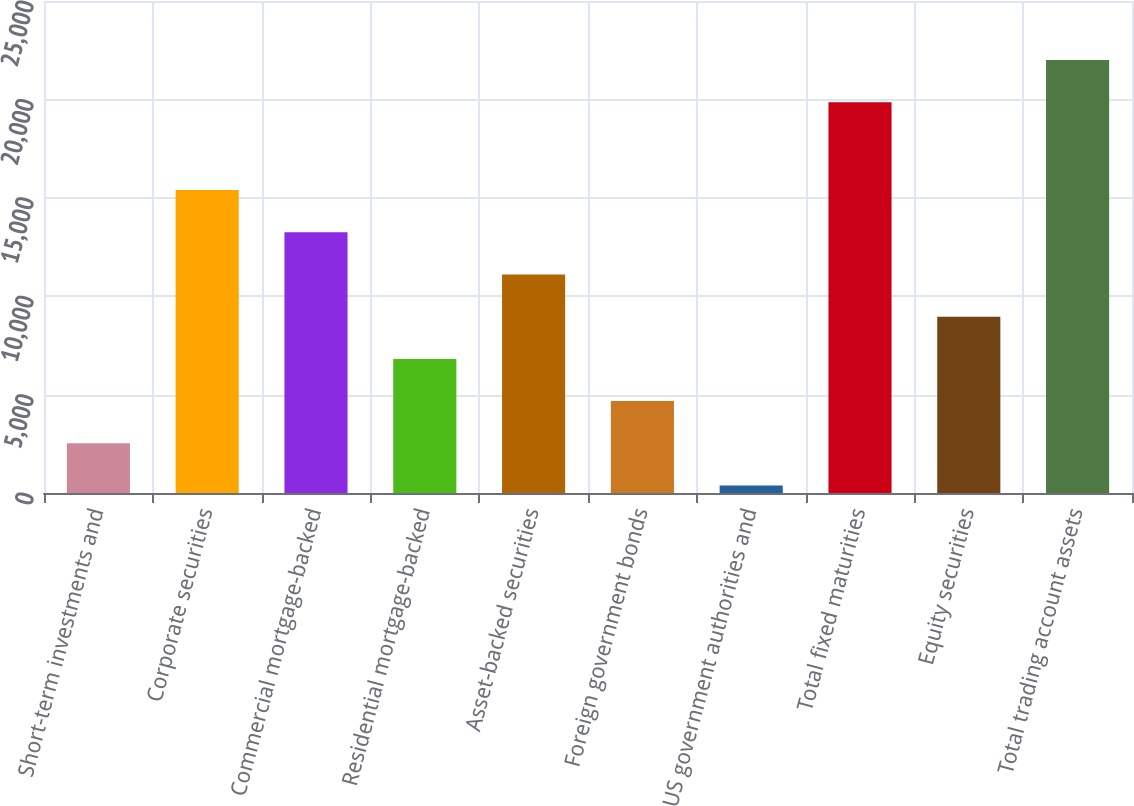Convert chart. <chart><loc_0><loc_0><loc_500><loc_500><bar_chart><fcel>Short-term investments and<fcel>Corporate securities<fcel>Commercial mortgage-backed<fcel>Residential mortgage-backed<fcel>Asset-backed securities<fcel>Foreign government bonds<fcel>US government authorities and<fcel>Total fixed maturities<fcel>Equity securities<fcel>Total trading account assets<nl><fcel>2522.4<fcel>15400.8<fcel>13254.4<fcel>6815.2<fcel>11108<fcel>4668.8<fcel>376<fcel>19850<fcel>8961.6<fcel>21996.4<nl></chart> 